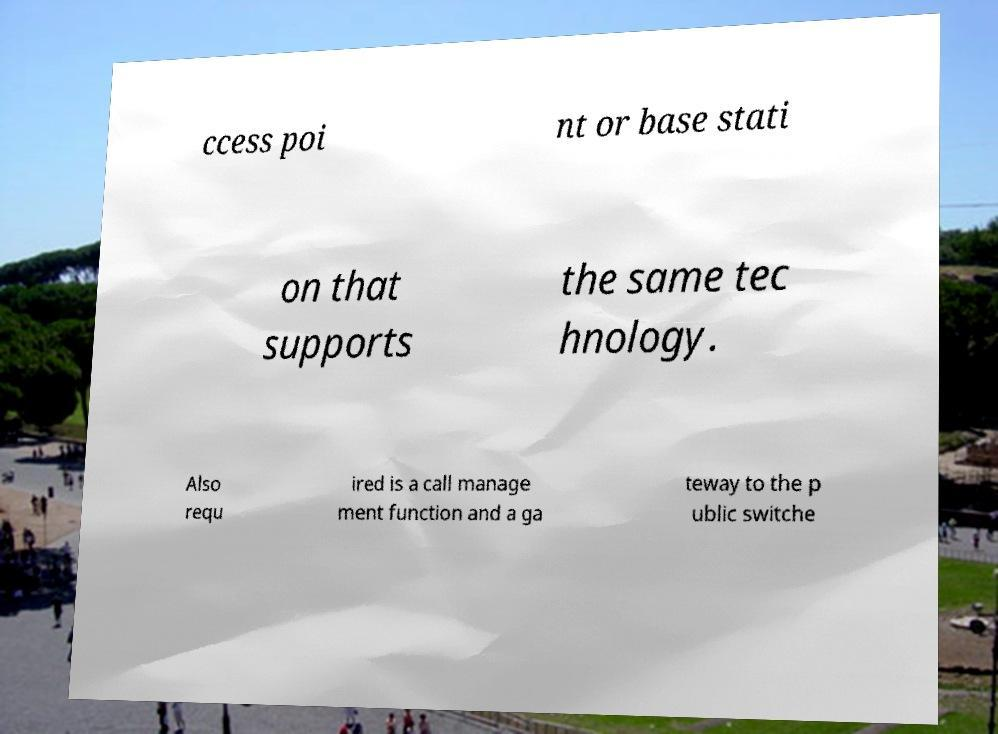For documentation purposes, I need the text within this image transcribed. Could you provide that? ccess poi nt or base stati on that supports the same tec hnology. Also requ ired is a call manage ment function and a ga teway to the p ublic switche 